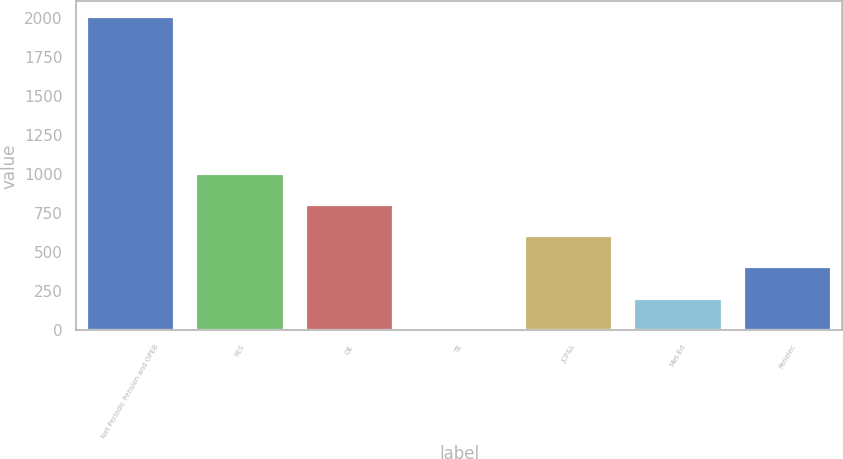Convert chart to OTSL. <chart><loc_0><loc_0><loc_500><loc_500><bar_chart><fcel>Net Periodic Pension and OPEB<fcel>FES<fcel>OE<fcel>TE<fcel>JCP&L<fcel>Met-Ed<fcel>Penelec<nl><fcel>2009<fcel>1005.5<fcel>804.8<fcel>2<fcel>604.1<fcel>202.7<fcel>403.4<nl></chart> 